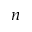<formula> <loc_0><loc_0><loc_500><loc_500>_ { n }</formula> 